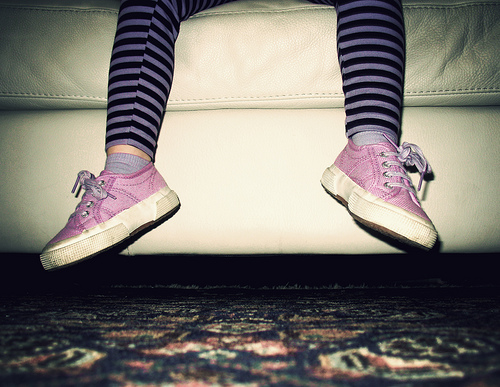<image>
Is there a sofa under the leggings? Yes. The sofa is positioned underneath the leggings, with the leggings above it in the vertical space. 